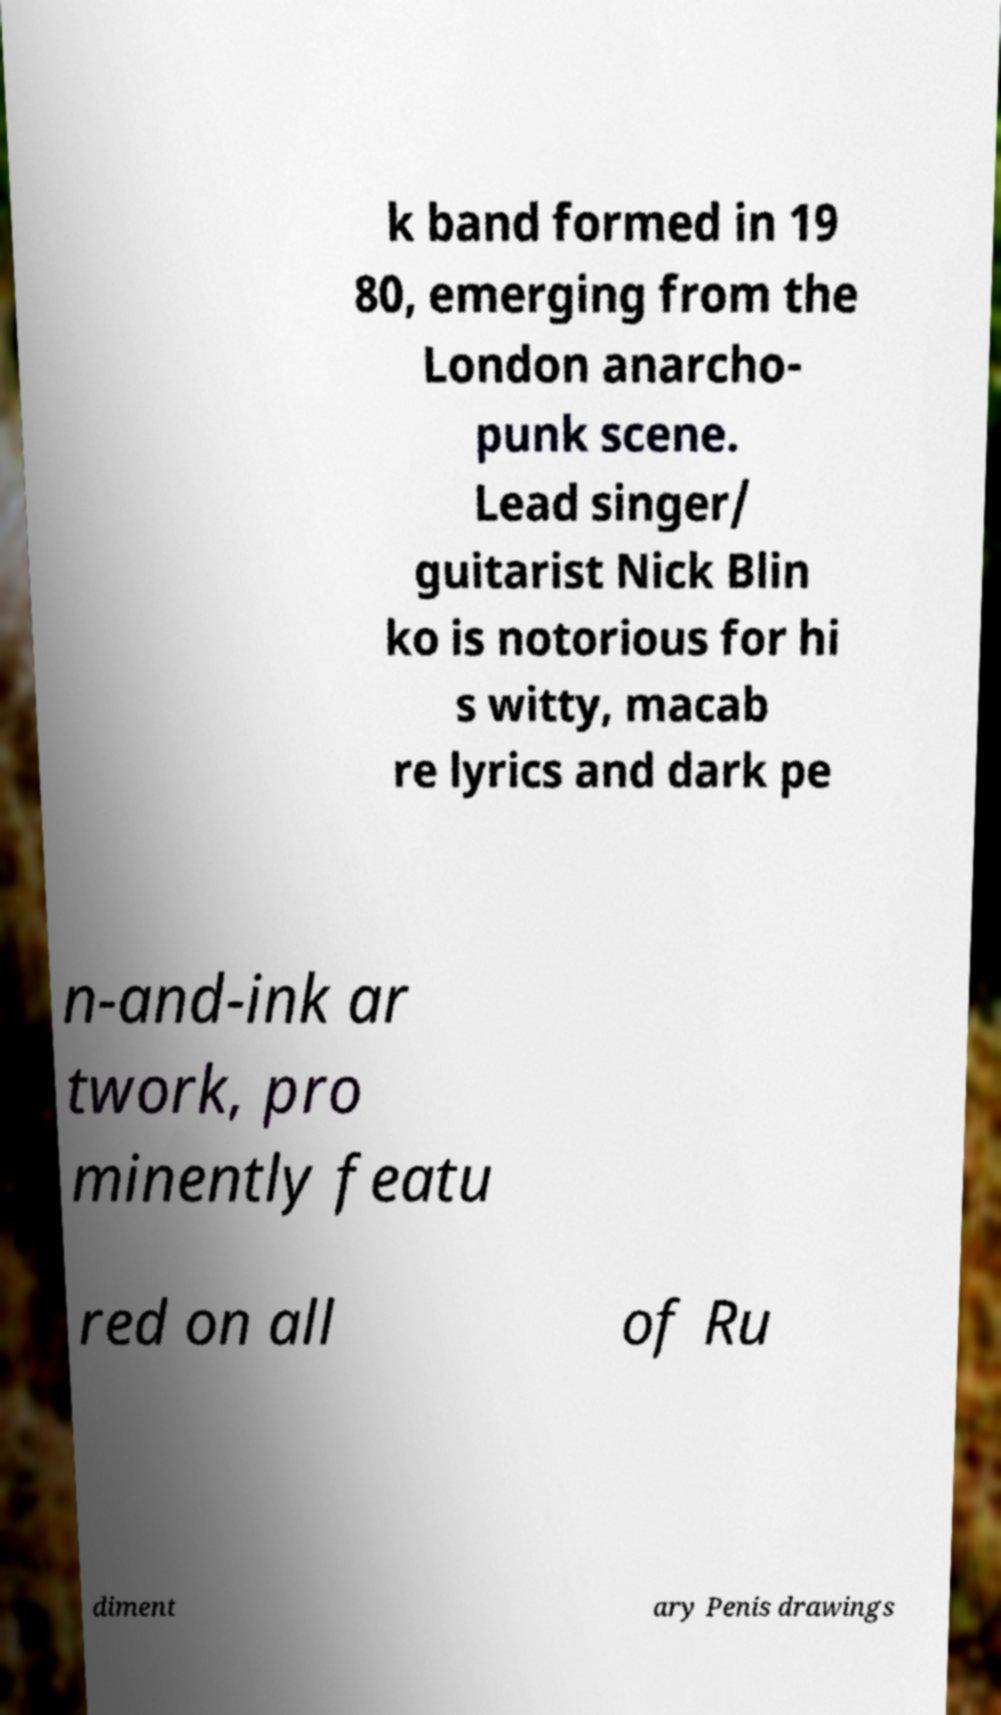Could you extract and type out the text from this image? k band formed in 19 80, emerging from the London anarcho- punk scene. Lead singer/ guitarist Nick Blin ko is notorious for hi s witty, macab re lyrics and dark pe n-and-ink ar twork, pro minently featu red on all of Ru diment ary Penis drawings 